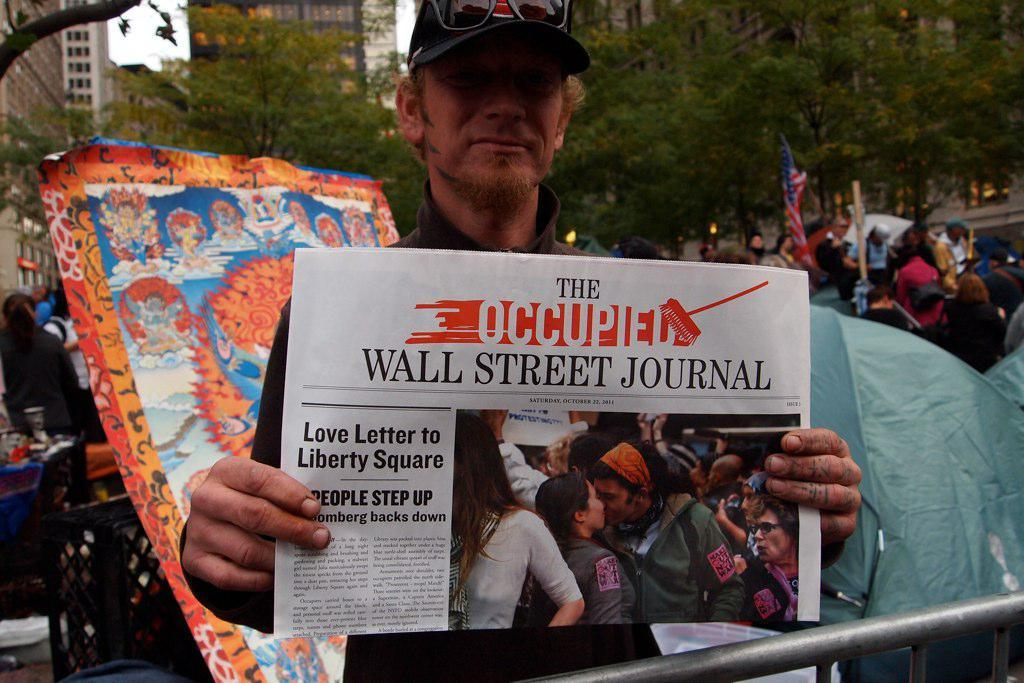<image>
Present a compact description of the photo's key features. A man wearing a hat holds up a Wall Street Journal Newspaper 